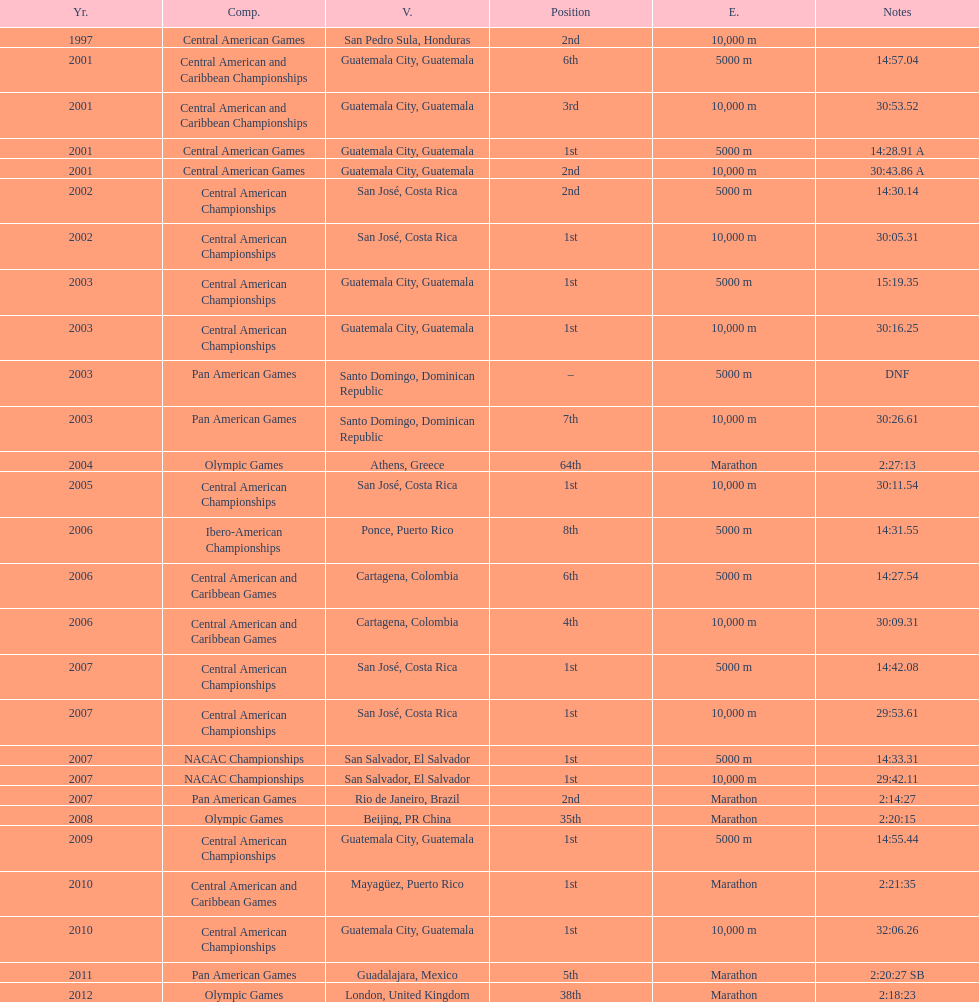What was the first competition this competitor competed in? Central American Games. 